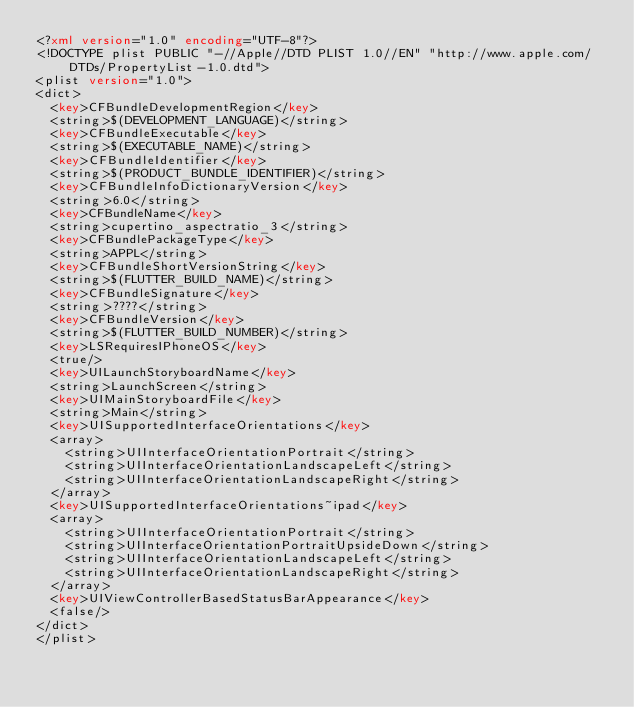<code> <loc_0><loc_0><loc_500><loc_500><_XML_><?xml version="1.0" encoding="UTF-8"?>
<!DOCTYPE plist PUBLIC "-//Apple//DTD PLIST 1.0//EN" "http://www.apple.com/DTDs/PropertyList-1.0.dtd">
<plist version="1.0">
<dict>
	<key>CFBundleDevelopmentRegion</key>
	<string>$(DEVELOPMENT_LANGUAGE)</string>
	<key>CFBundleExecutable</key>
	<string>$(EXECUTABLE_NAME)</string>
	<key>CFBundleIdentifier</key>
	<string>$(PRODUCT_BUNDLE_IDENTIFIER)</string>
	<key>CFBundleInfoDictionaryVersion</key>
	<string>6.0</string>
	<key>CFBundleName</key>
	<string>cupertino_aspectratio_3</string>
	<key>CFBundlePackageType</key>
	<string>APPL</string>
	<key>CFBundleShortVersionString</key>
	<string>$(FLUTTER_BUILD_NAME)</string>
	<key>CFBundleSignature</key>
	<string>????</string>
	<key>CFBundleVersion</key>
	<string>$(FLUTTER_BUILD_NUMBER)</string>
	<key>LSRequiresIPhoneOS</key>
	<true/>
	<key>UILaunchStoryboardName</key>
	<string>LaunchScreen</string>
	<key>UIMainStoryboardFile</key>
	<string>Main</string>
	<key>UISupportedInterfaceOrientations</key>
	<array>
		<string>UIInterfaceOrientationPortrait</string>
		<string>UIInterfaceOrientationLandscapeLeft</string>
		<string>UIInterfaceOrientationLandscapeRight</string>
	</array>
	<key>UISupportedInterfaceOrientations~ipad</key>
	<array>
		<string>UIInterfaceOrientationPortrait</string>
		<string>UIInterfaceOrientationPortraitUpsideDown</string>
		<string>UIInterfaceOrientationLandscapeLeft</string>
		<string>UIInterfaceOrientationLandscapeRight</string>
	</array>
	<key>UIViewControllerBasedStatusBarAppearance</key>
	<false/>
</dict>
</plist>
</code> 